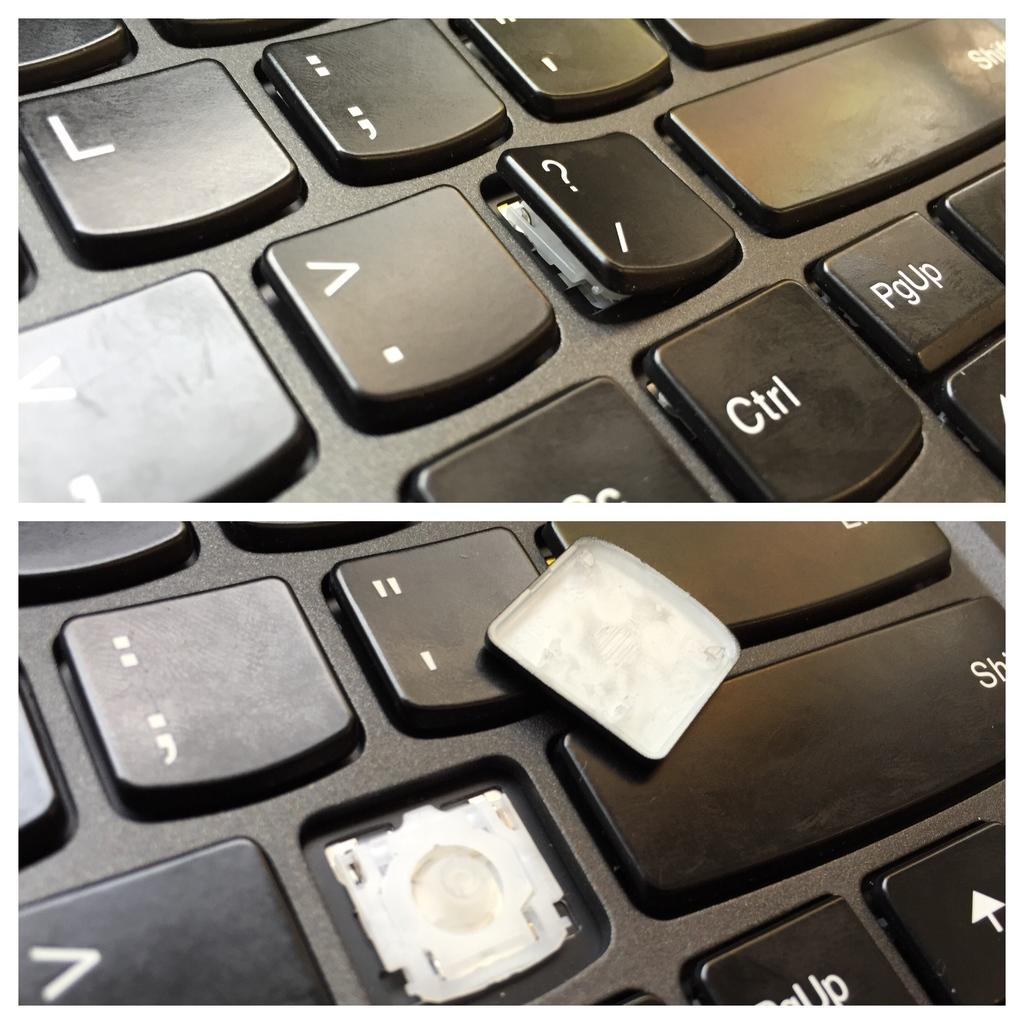<image>
Relay a brief, clear account of the picture shown. A broken key is next to the control and page up key on a computer keyboard. 